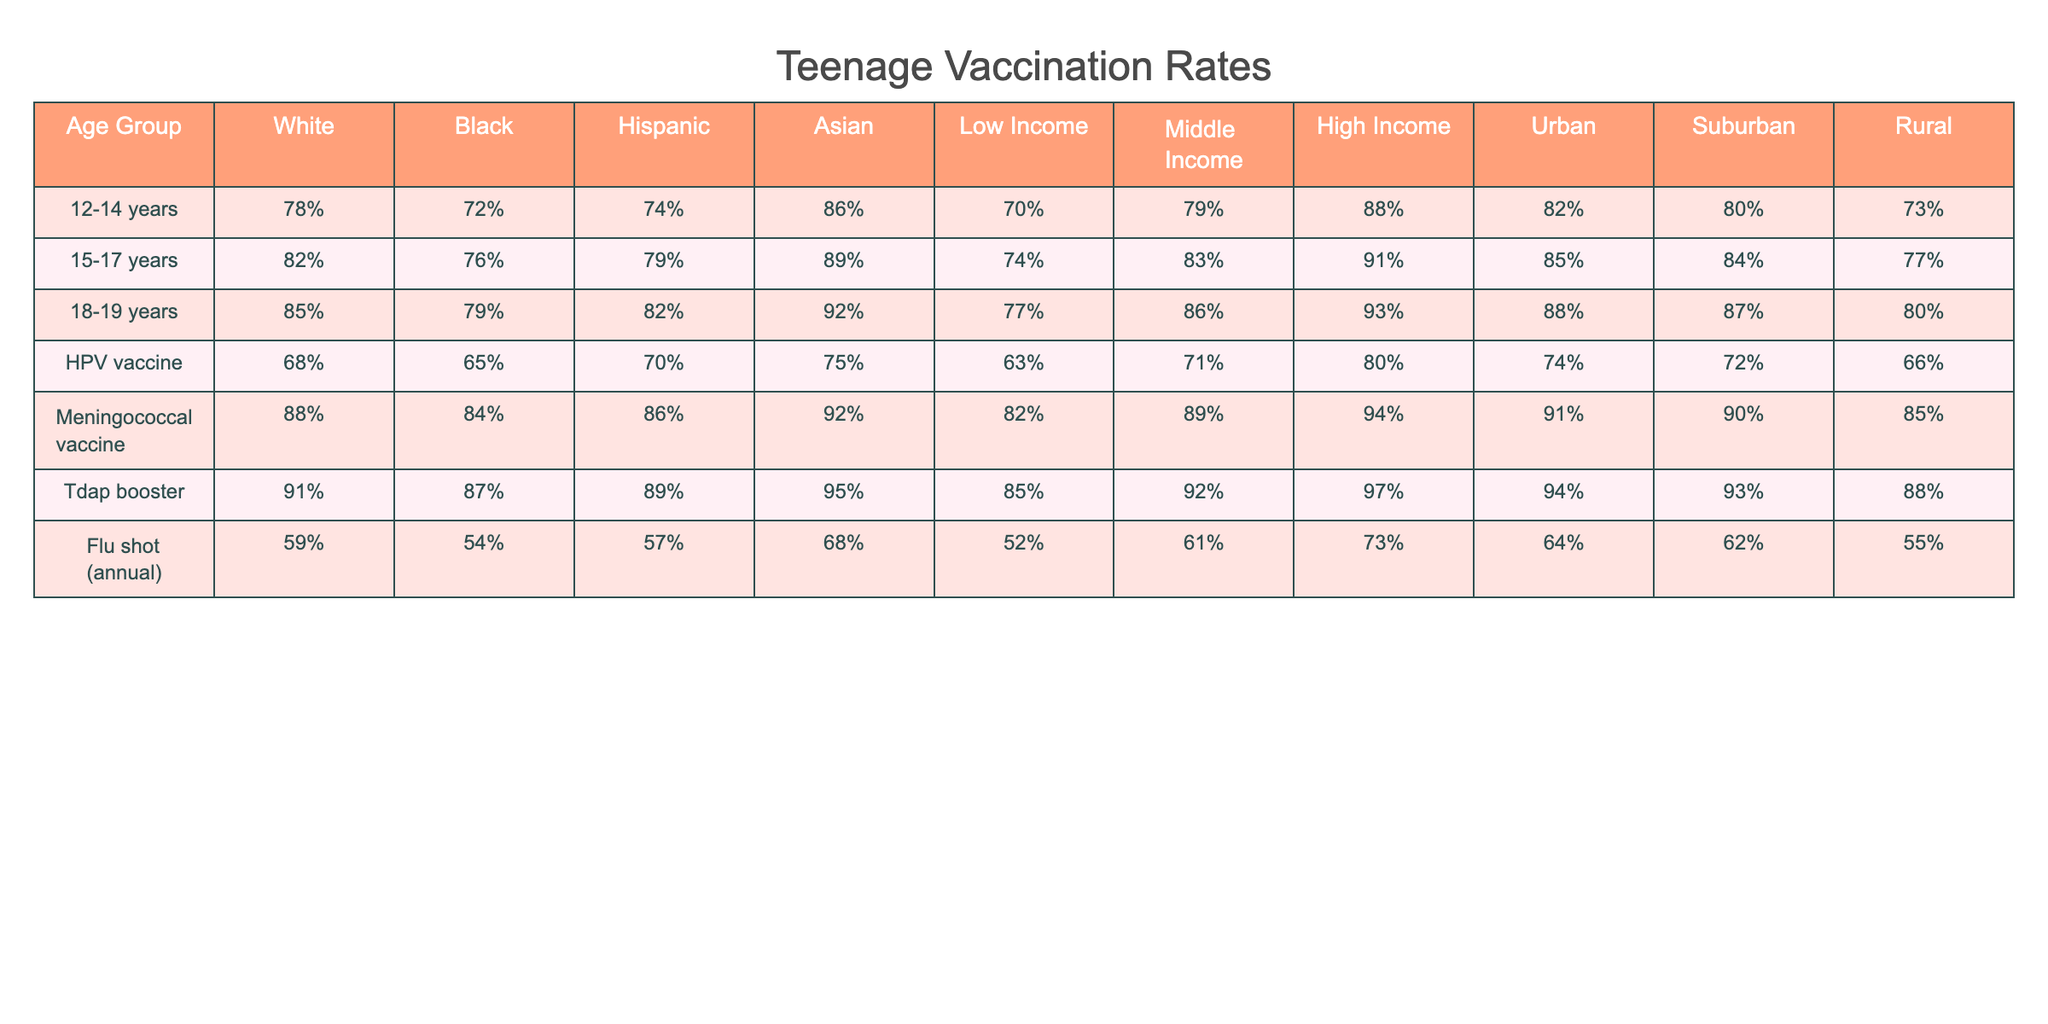What percentage of 12-14 year old White teenagers have received the Tdap booster? Looking at the Tdap booster row and the 12-14 years column under the White demographic, the percentage is 91%.
Answer: 91% What is the vaccination rate for the Flu shot among 15-17 year old Hispanic teenagers? Under the Flu shot row and the 15-17 years column for Hispanic, the rate is 79%.
Answer: 79% Which age group has the highest vaccination rate for the Meningococcal vaccine overall? By comparing all age groups under the Meningococcal vaccine row, the 18-19 years age group has the highest rate at 92%.
Answer: 18-19 years Is the vaccination rate for the HPV vaccine among Black teenagers higher than that of Hispanic teenagers? Comparing the HPV vaccine rates, Black teenagers have 65% and Hispanic teenagers have 70%. Since 70% is greater than 65%, the statement is false.
Answer: No What is the average vaccination rate for Tdap booster among low-income teenagers? The Tdap booster rate for low-income teenagers is 85%. Since there is only one data point in this category, this is also the average.
Answer: 85% Which demographic group has the lowest vaccination rate for the Flu shot? Under the Flu shot row, checking each demographic group shows that the lowest rate is for Low Income at 52%.
Answer: Low Income What is the difference in vaccination rates for the Meningococcal vaccine between urban and rural teenagers aged 15-17 years? The urban rate for Meningococcal vaccine is 85% and rural is 77%. The difference is calculated as 85% - 77% = 8%.
Answer: 8% For the Asian demographic, what is the percentage of 18-19-year-olds who received the Tdap booster? Looking at the Tdap booster row and the 18-19 years column for Asian, the percentage is 95%.
Answer: 95% How does the overall Tdap booster vaccination rate for 12-14 year olds compare to that of 18-19 year olds? The Tdap booster rate for 12-14 year olds is 91%, and for 18-19 year olds, it is 95%. The difference shows that 18-19 year olds have a higher rate by 4%.
Answer: 4% higher What percentage of middle-income teenagers received the Flu shot? In the Flu shot row, the rate for middle-income teenagers is 61%.
Answer: 61% 